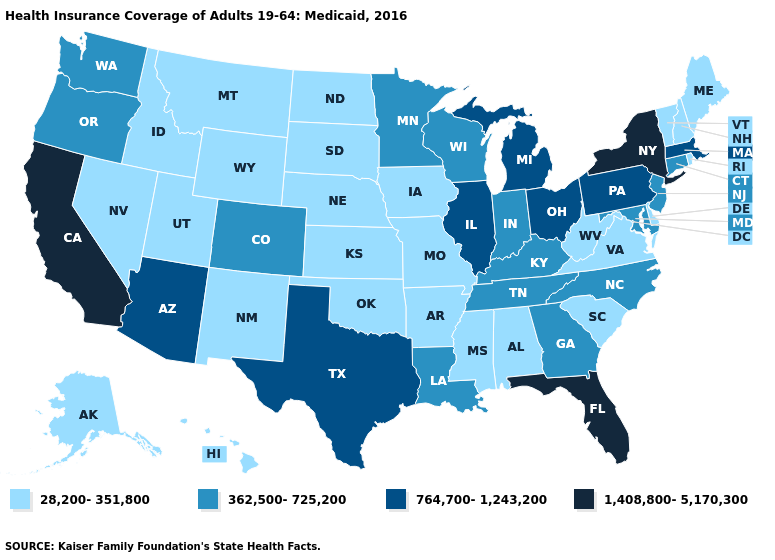Is the legend a continuous bar?
Concise answer only. No. Name the states that have a value in the range 28,200-351,800?
Keep it brief. Alabama, Alaska, Arkansas, Delaware, Hawaii, Idaho, Iowa, Kansas, Maine, Mississippi, Missouri, Montana, Nebraska, Nevada, New Hampshire, New Mexico, North Dakota, Oklahoma, Rhode Island, South Carolina, South Dakota, Utah, Vermont, Virginia, West Virginia, Wyoming. What is the value of Indiana?
Quick response, please. 362,500-725,200. Name the states that have a value in the range 362,500-725,200?
Give a very brief answer. Colorado, Connecticut, Georgia, Indiana, Kentucky, Louisiana, Maryland, Minnesota, New Jersey, North Carolina, Oregon, Tennessee, Washington, Wisconsin. What is the lowest value in the Northeast?
Be succinct. 28,200-351,800. Does Connecticut have a lower value than Michigan?
Short answer required. Yes. What is the highest value in the USA?
Quick response, please. 1,408,800-5,170,300. What is the highest value in the West ?
Short answer required. 1,408,800-5,170,300. Which states have the highest value in the USA?
Answer briefly. California, Florida, New York. What is the value of Mississippi?
Quick response, please. 28,200-351,800. What is the highest value in states that border California?
Give a very brief answer. 764,700-1,243,200. Does Alaska have the lowest value in the West?
Give a very brief answer. Yes. What is the value of California?
Give a very brief answer. 1,408,800-5,170,300. Name the states that have a value in the range 1,408,800-5,170,300?
Keep it brief. California, Florida, New York. Does Washington have the highest value in the USA?
Answer briefly. No. 